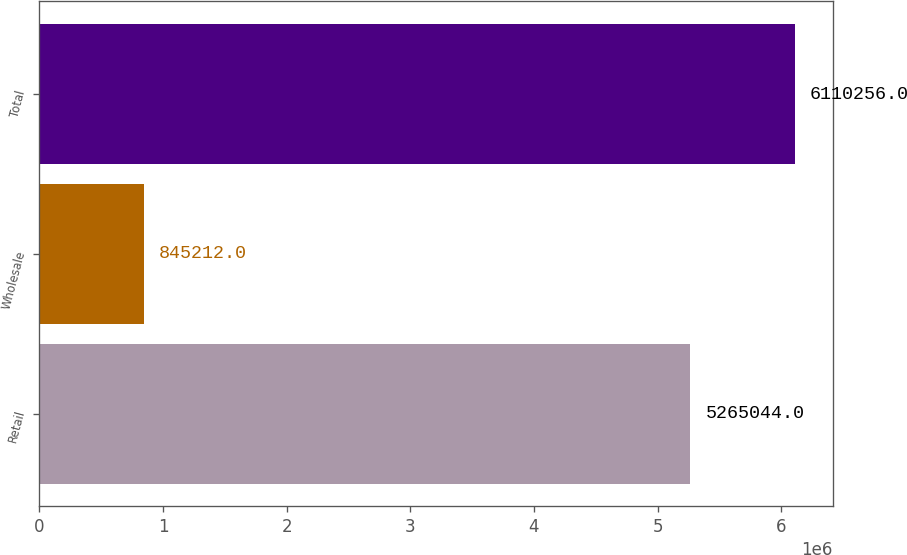Convert chart. <chart><loc_0><loc_0><loc_500><loc_500><bar_chart><fcel>Retail<fcel>Wholesale<fcel>Total<nl><fcel>5.26504e+06<fcel>845212<fcel>6.11026e+06<nl></chart> 